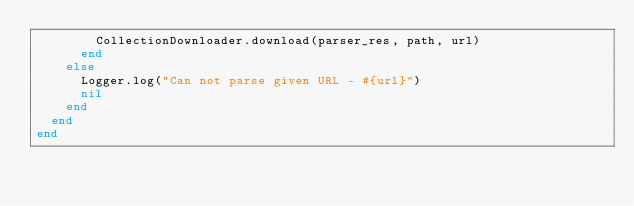Convert code to text. <code><loc_0><loc_0><loc_500><loc_500><_Ruby_>        CollectionDownloader.download(parser_res, path, url)
      end
    else
      Logger.log("Can not parse given URL - #{url}")
      nil
    end
  end
end
</code> 